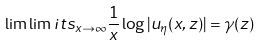<formula> <loc_0><loc_0><loc_500><loc_500>\lim \lim i t s _ { x \to \infty } \frac { 1 } { x } \log | u _ { \eta } ( x , z ) | = \gamma ( z )</formula> 